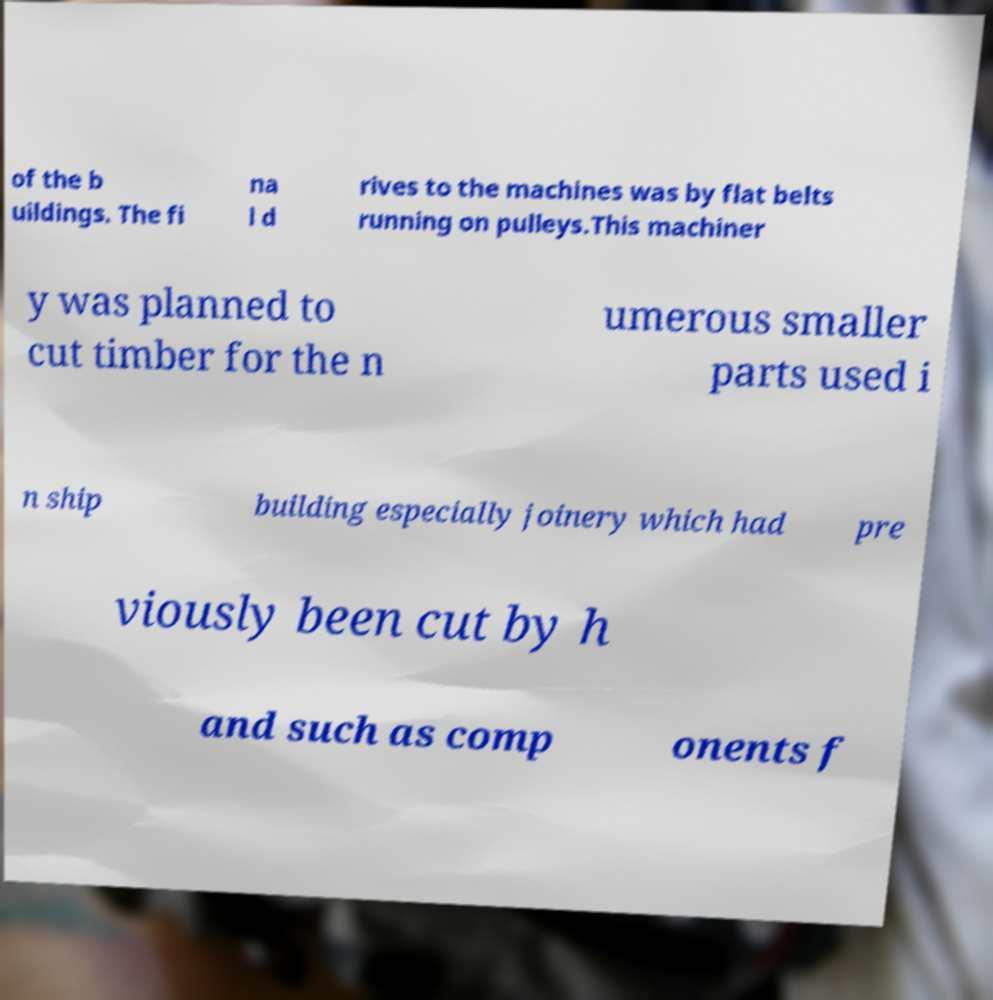I need the written content from this picture converted into text. Can you do that? of the b uildings. The fi na l d rives to the machines was by flat belts running on pulleys.This machiner y was planned to cut timber for the n umerous smaller parts used i n ship building especially joinery which had pre viously been cut by h and such as comp onents f 